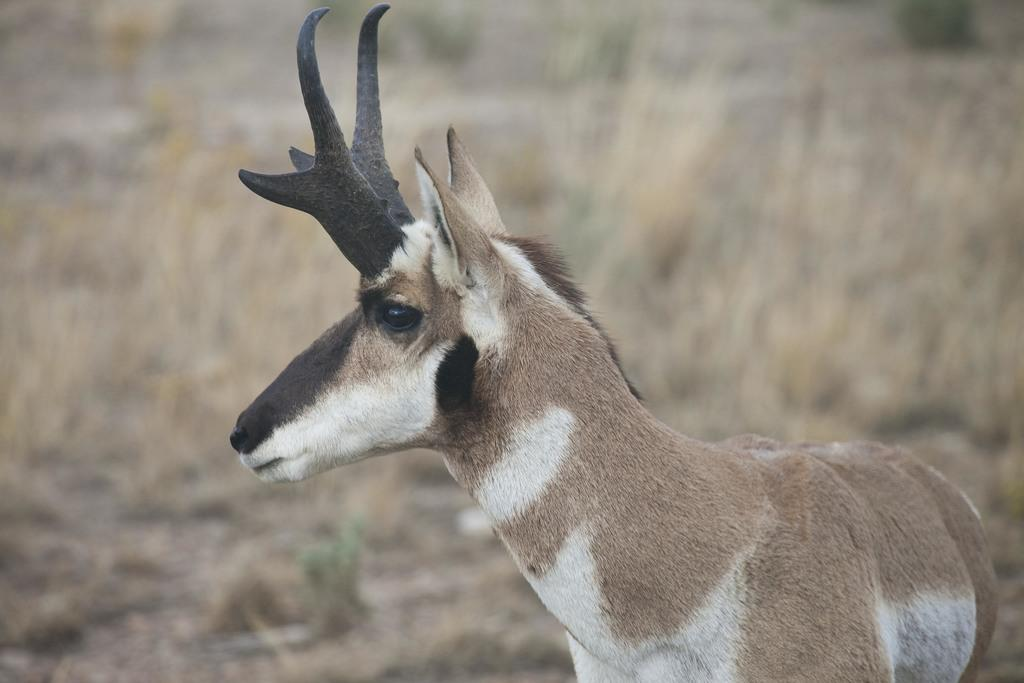What animal is in the picture? There is a reindeer in the picture. What is the reindeer's position in relation to the ground? The reindeer is standing on the ground. What type of vegetation is present on the floor? There is grass on the floor. What can be seen in the background of the picture? There are trees in the background of the picture. What is the condition of the iron in the picture? There is no iron present in the picture; it features a reindeer standing on grass with trees in the background. 